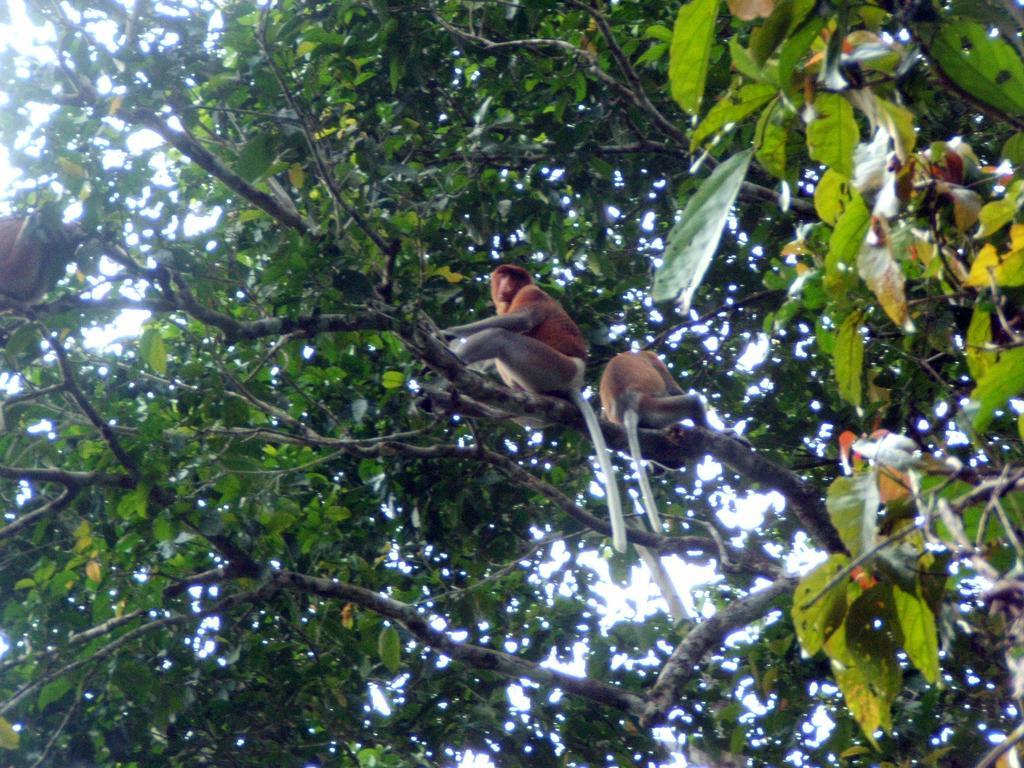How would you summarize this image in a sentence or two? Here in this image I can see number of monkeys on branch of a tree. 